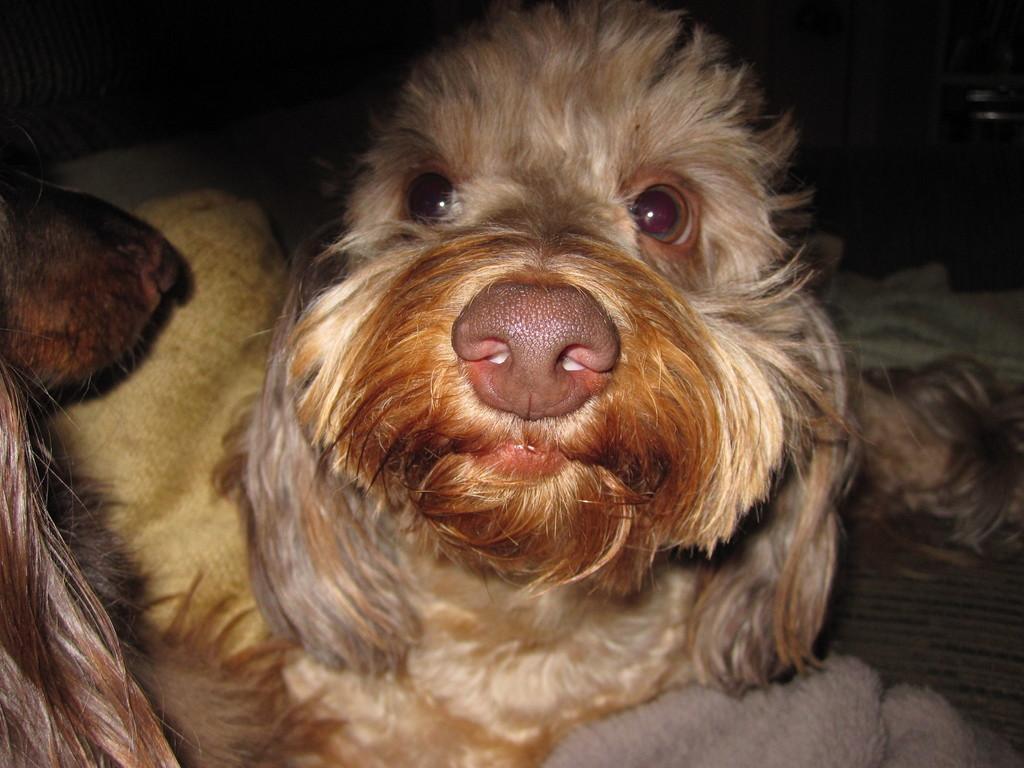Could you give a brief overview of what you see in this image? In this image we can see two dogs. The background is dark. It seems like a towel at the bottom of the image. 